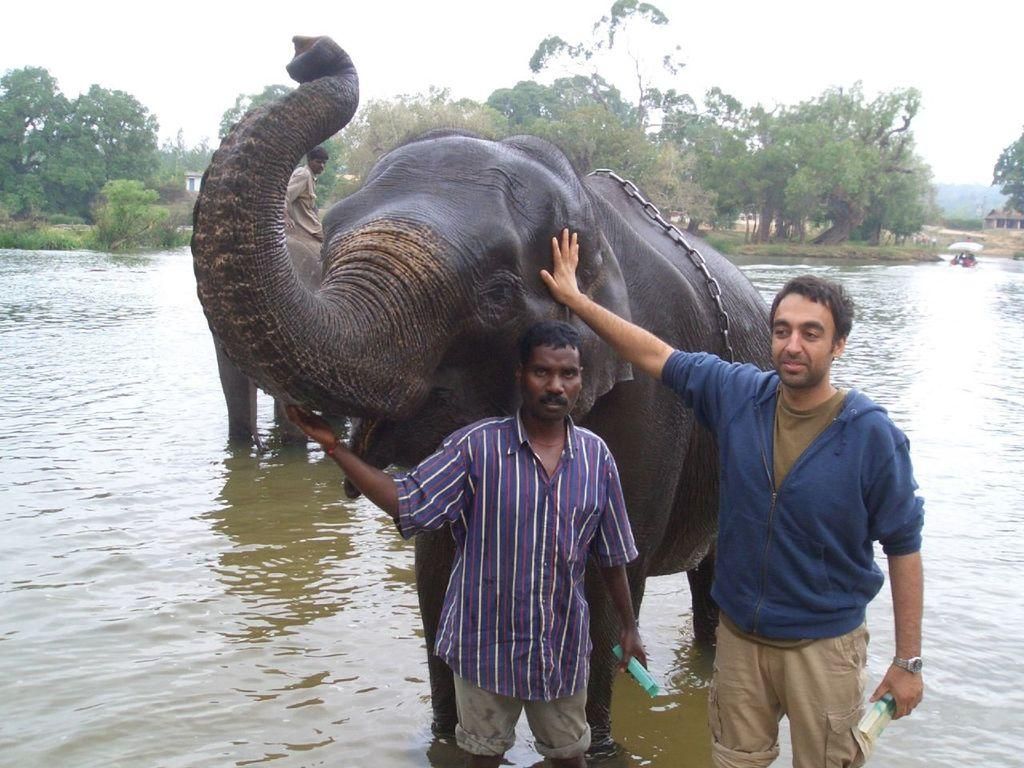How many people are in the image? There are two persons in the image. What are the two persons doing in the image? The two persons are touching an elephant. Where is the elephant located in the image? The elephant is in water. What can be seen in the background of the image? There are trees visible in the background of the image. What type of hat is the elephant wearing in the image? There is no hat present on the elephant in the image. 